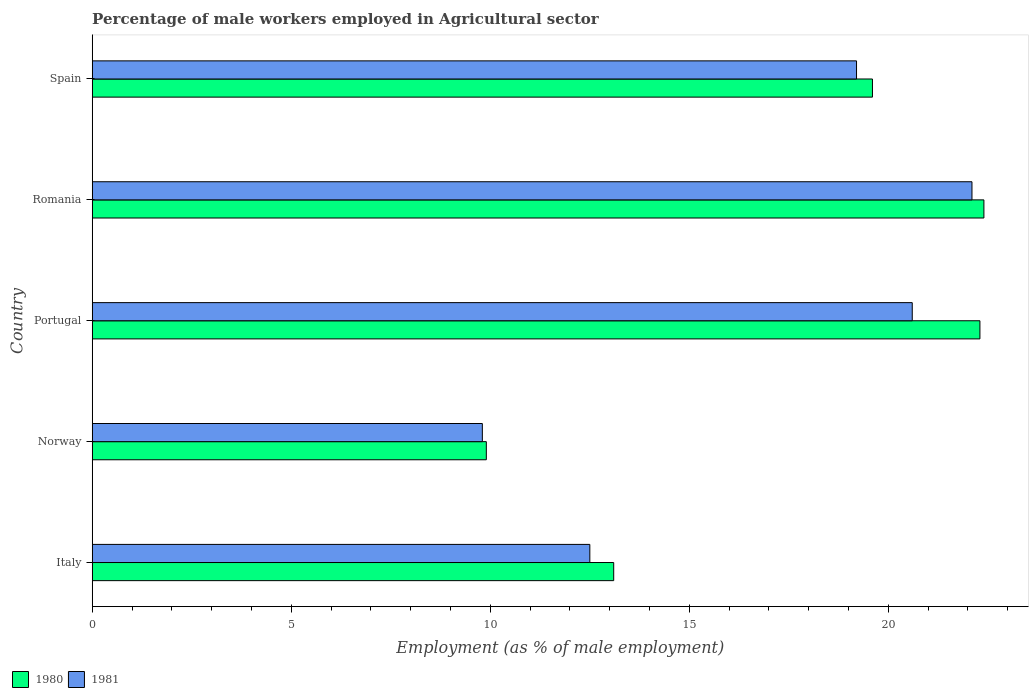Are the number of bars on each tick of the Y-axis equal?
Provide a succinct answer. Yes. What is the label of the 1st group of bars from the top?
Keep it short and to the point. Spain. What is the percentage of male workers employed in Agricultural sector in 1980 in Portugal?
Provide a succinct answer. 22.3. Across all countries, what is the maximum percentage of male workers employed in Agricultural sector in 1980?
Your response must be concise. 22.4. Across all countries, what is the minimum percentage of male workers employed in Agricultural sector in 1980?
Provide a short and direct response. 9.9. In which country was the percentage of male workers employed in Agricultural sector in 1981 maximum?
Give a very brief answer. Romania. In which country was the percentage of male workers employed in Agricultural sector in 1981 minimum?
Keep it short and to the point. Norway. What is the total percentage of male workers employed in Agricultural sector in 1981 in the graph?
Your answer should be compact. 84.2. What is the difference between the percentage of male workers employed in Agricultural sector in 1980 in Portugal and that in Romania?
Offer a very short reply. -0.1. What is the difference between the percentage of male workers employed in Agricultural sector in 1981 in Romania and the percentage of male workers employed in Agricultural sector in 1980 in Norway?
Keep it short and to the point. 12.2. What is the average percentage of male workers employed in Agricultural sector in 1981 per country?
Give a very brief answer. 16.84. What is the difference between the percentage of male workers employed in Agricultural sector in 1981 and percentage of male workers employed in Agricultural sector in 1980 in Romania?
Offer a very short reply. -0.3. What is the ratio of the percentage of male workers employed in Agricultural sector in 1981 in Norway to that in Romania?
Your answer should be very brief. 0.44. Is the percentage of male workers employed in Agricultural sector in 1980 in Norway less than that in Portugal?
Ensure brevity in your answer.  Yes. Is the difference between the percentage of male workers employed in Agricultural sector in 1981 in Norway and Spain greater than the difference between the percentage of male workers employed in Agricultural sector in 1980 in Norway and Spain?
Provide a short and direct response. Yes. What is the difference between the highest and the second highest percentage of male workers employed in Agricultural sector in 1980?
Give a very brief answer. 0.1. What is the difference between the highest and the lowest percentage of male workers employed in Agricultural sector in 1980?
Provide a succinct answer. 12.5. In how many countries, is the percentage of male workers employed in Agricultural sector in 1981 greater than the average percentage of male workers employed in Agricultural sector in 1981 taken over all countries?
Your response must be concise. 3. Is the sum of the percentage of male workers employed in Agricultural sector in 1981 in Italy and Norway greater than the maximum percentage of male workers employed in Agricultural sector in 1980 across all countries?
Keep it short and to the point. No. What is the difference between two consecutive major ticks on the X-axis?
Provide a short and direct response. 5. Are the values on the major ticks of X-axis written in scientific E-notation?
Offer a terse response. No. How are the legend labels stacked?
Your response must be concise. Horizontal. What is the title of the graph?
Keep it short and to the point. Percentage of male workers employed in Agricultural sector. What is the label or title of the X-axis?
Make the answer very short. Employment (as % of male employment). What is the Employment (as % of male employment) in 1980 in Italy?
Offer a very short reply. 13.1. What is the Employment (as % of male employment) in 1980 in Norway?
Your response must be concise. 9.9. What is the Employment (as % of male employment) in 1981 in Norway?
Make the answer very short. 9.8. What is the Employment (as % of male employment) in 1980 in Portugal?
Your answer should be compact. 22.3. What is the Employment (as % of male employment) in 1981 in Portugal?
Make the answer very short. 20.6. What is the Employment (as % of male employment) in 1980 in Romania?
Keep it short and to the point. 22.4. What is the Employment (as % of male employment) in 1981 in Romania?
Offer a very short reply. 22.1. What is the Employment (as % of male employment) in 1980 in Spain?
Your answer should be very brief. 19.6. What is the Employment (as % of male employment) in 1981 in Spain?
Keep it short and to the point. 19.2. Across all countries, what is the maximum Employment (as % of male employment) in 1980?
Give a very brief answer. 22.4. Across all countries, what is the maximum Employment (as % of male employment) in 1981?
Your answer should be very brief. 22.1. Across all countries, what is the minimum Employment (as % of male employment) in 1980?
Ensure brevity in your answer.  9.9. Across all countries, what is the minimum Employment (as % of male employment) of 1981?
Give a very brief answer. 9.8. What is the total Employment (as % of male employment) in 1980 in the graph?
Make the answer very short. 87.3. What is the total Employment (as % of male employment) in 1981 in the graph?
Offer a very short reply. 84.2. What is the difference between the Employment (as % of male employment) in 1980 in Italy and that in Norway?
Give a very brief answer. 3.2. What is the difference between the Employment (as % of male employment) in 1981 in Italy and that in Norway?
Your answer should be very brief. 2.7. What is the difference between the Employment (as % of male employment) in 1980 in Italy and that in Portugal?
Ensure brevity in your answer.  -9.2. What is the difference between the Employment (as % of male employment) of 1981 in Italy and that in Portugal?
Offer a very short reply. -8.1. What is the difference between the Employment (as % of male employment) in 1981 in Italy and that in Romania?
Make the answer very short. -9.6. What is the difference between the Employment (as % of male employment) of 1981 in Italy and that in Spain?
Your response must be concise. -6.7. What is the difference between the Employment (as % of male employment) in 1980 in Norway and that in Portugal?
Your answer should be very brief. -12.4. What is the difference between the Employment (as % of male employment) of 1981 in Norway and that in Portugal?
Keep it short and to the point. -10.8. What is the difference between the Employment (as % of male employment) in 1980 in Norway and that in Romania?
Provide a short and direct response. -12.5. What is the difference between the Employment (as % of male employment) of 1981 in Norway and that in Spain?
Keep it short and to the point. -9.4. What is the difference between the Employment (as % of male employment) in 1981 in Portugal and that in Romania?
Your answer should be very brief. -1.5. What is the difference between the Employment (as % of male employment) of 1980 in Portugal and that in Spain?
Give a very brief answer. 2.7. What is the difference between the Employment (as % of male employment) of 1981 in Portugal and that in Spain?
Provide a short and direct response. 1.4. What is the difference between the Employment (as % of male employment) of 1980 in Romania and that in Spain?
Ensure brevity in your answer.  2.8. What is the difference between the Employment (as % of male employment) of 1980 in Italy and the Employment (as % of male employment) of 1981 in Romania?
Keep it short and to the point. -9. What is the difference between the Employment (as % of male employment) in 1980 in Italy and the Employment (as % of male employment) in 1981 in Spain?
Keep it short and to the point. -6.1. What is the difference between the Employment (as % of male employment) in 1980 in Norway and the Employment (as % of male employment) in 1981 in Portugal?
Provide a short and direct response. -10.7. What is the difference between the Employment (as % of male employment) of 1980 in Norway and the Employment (as % of male employment) of 1981 in Romania?
Your answer should be compact. -12.2. What is the difference between the Employment (as % of male employment) in 1980 in Norway and the Employment (as % of male employment) in 1981 in Spain?
Your answer should be compact. -9.3. What is the difference between the Employment (as % of male employment) in 1980 in Portugal and the Employment (as % of male employment) in 1981 in Romania?
Make the answer very short. 0.2. What is the difference between the Employment (as % of male employment) in 1980 in Portugal and the Employment (as % of male employment) in 1981 in Spain?
Make the answer very short. 3.1. What is the average Employment (as % of male employment) of 1980 per country?
Ensure brevity in your answer.  17.46. What is the average Employment (as % of male employment) in 1981 per country?
Your response must be concise. 16.84. What is the difference between the Employment (as % of male employment) in 1980 and Employment (as % of male employment) in 1981 in Norway?
Provide a succinct answer. 0.1. What is the difference between the Employment (as % of male employment) in 1980 and Employment (as % of male employment) in 1981 in Portugal?
Offer a terse response. 1.7. What is the difference between the Employment (as % of male employment) in 1980 and Employment (as % of male employment) in 1981 in Romania?
Your answer should be compact. 0.3. What is the ratio of the Employment (as % of male employment) in 1980 in Italy to that in Norway?
Offer a terse response. 1.32. What is the ratio of the Employment (as % of male employment) in 1981 in Italy to that in Norway?
Ensure brevity in your answer.  1.28. What is the ratio of the Employment (as % of male employment) of 1980 in Italy to that in Portugal?
Offer a terse response. 0.59. What is the ratio of the Employment (as % of male employment) of 1981 in Italy to that in Portugal?
Provide a succinct answer. 0.61. What is the ratio of the Employment (as % of male employment) of 1980 in Italy to that in Romania?
Offer a terse response. 0.58. What is the ratio of the Employment (as % of male employment) in 1981 in Italy to that in Romania?
Provide a short and direct response. 0.57. What is the ratio of the Employment (as % of male employment) of 1980 in Italy to that in Spain?
Your answer should be very brief. 0.67. What is the ratio of the Employment (as % of male employment) in 1981 in Italy to that in Spain?
Give a very brief answer. 0.65. What is the ratio of the Employment (as % of male employment) in 1980 in Norway to that in Portugal?
Provide a succinct answer. 0.44. What is the ratio of the Employment (as % of male employment) in 1981 in Norway to that in Portugal?
Your response must be concise. 0.48. What is the ratio of the Employment (as % of male employment) in 1980 in Norway to that in Romania?
Your response must be concise. 0.44. What is the ratio of the Employment (as % of male employment) in 1981 in Norway to that in Romania?
Ensure brevity in your answer.  0.44. What is the ratio of the Employment (as % of male employment) of 1980 in Norway to that in Spain?
Your answer should be very brief. 0.51. What is the ratio of the Employment (as % of male employment) in 1981 in Norway to that in Spain?
Your response must be concise. 0.51. What is the ratio of the Employment (as % of male employment) in 1981 in Portugal to that in Romania?
Your answer should be compact. 0.93. What is the ratio of the Employment (as % of male employment) in 1980 in Portugal to that in Spain?
Give a very brief answer. 1.14. What is the ratio of the Employment (as % of male employment) in 1981 in Portugal to that in Spain?
Ensure brevity in your answer.  1.07. What is the ratio of the Employment (as % of male employment) in 1980 in Romania to that in Spain?
Offer a very short reply. 1.14. What is the ratio of the Employment (as % of male employment) in 1981 in Romania to that in Spain?
Keep it short and to the point. 1.15. What is the difference between the highest and the second highest Employment (as % of male employment) of 1980?
Give a very brief answer. 0.1. What is the difference between the highest and the second highest Employment (as % of male employment) in 1981?
Give a very brief answer. 1.5. 